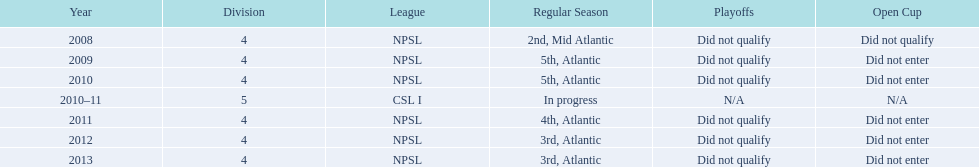What was the last year they came in 3rd place 2013. 